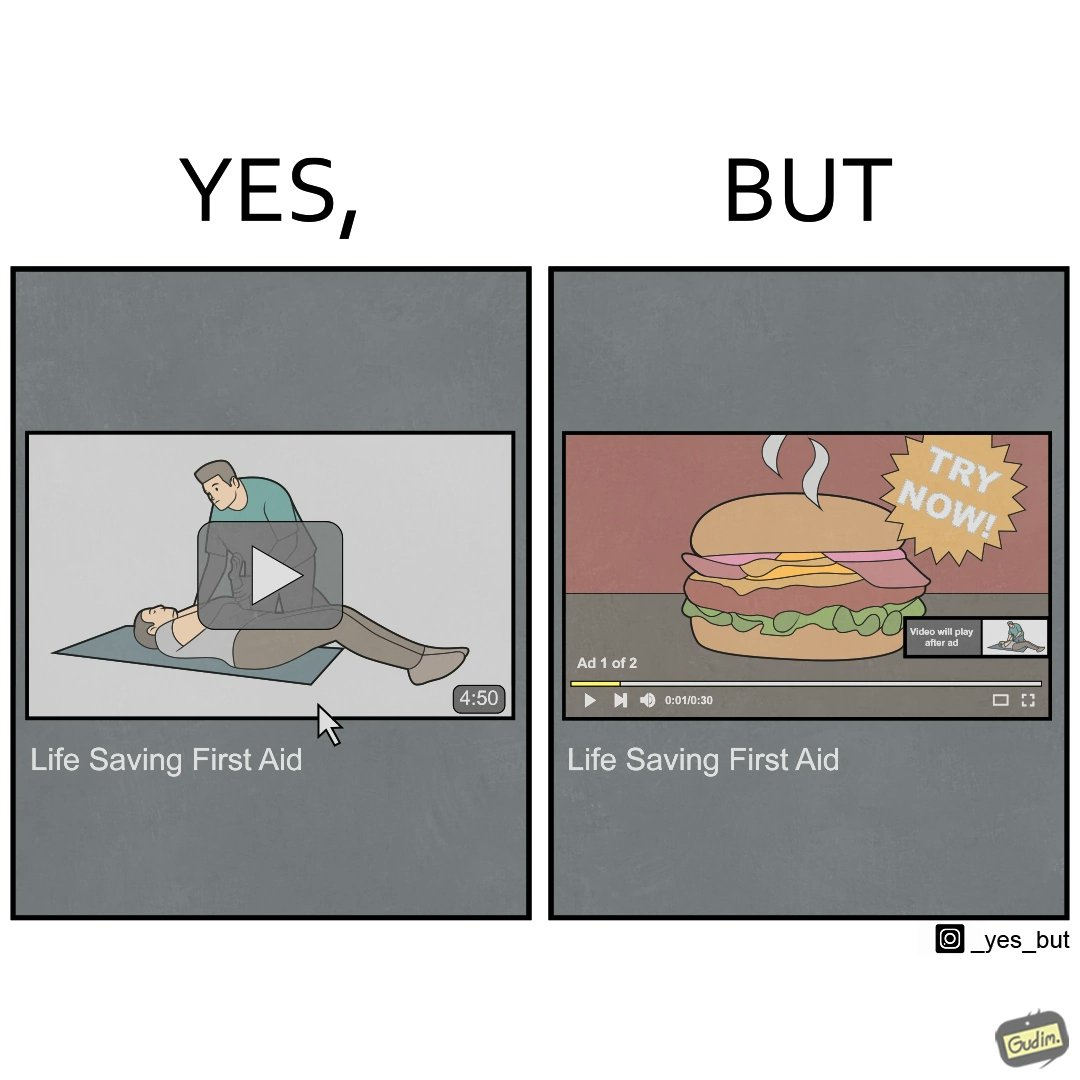Describe the content of this image. The image is ironical, as when watching a video of 4 mins 50 secs on "Life Saving First Aid", you have to see two ads, the first of which is a lengthy ad of 30 secs, and is a Burger Commercial, which is harmful for health and life, contradictory to the original video. 